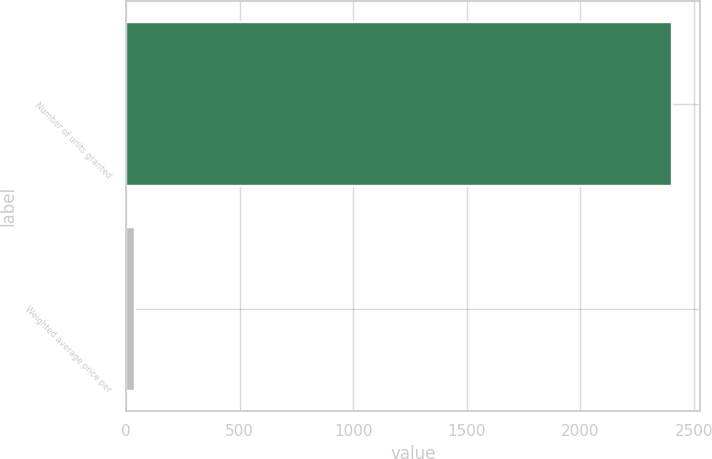Convert chart. <chart><loc_0><loc_0><loc_500><loc_500><bar_chart><fcel>Number of units granted<fcel>Weighted average price per<nl><fcel>2404.9<fcel>38.41<nl></chart> 